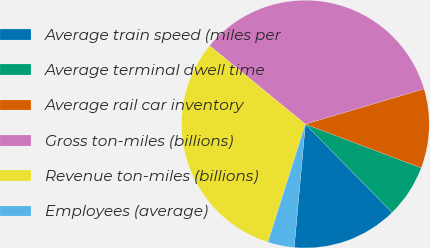<chart> <loc_0><loc_0><loc_500><loc_500><pie_chart><fcel>Average train speed (miles per<fcel>Average terminal dwell time<fcel>Average rail car inventory<fcel>Gross ton-miles (billions)<fcel>Revenue ton-miles (billions)<fcel>Employees (average)<nl><fcel>13.79%<fcel>6.9%<fcel>10.34%<fcel>34.48%<fcel>31.03%<fcel>3.45%<nl></chart> 